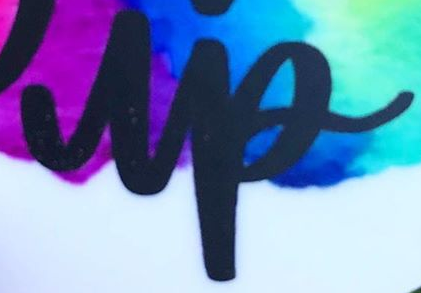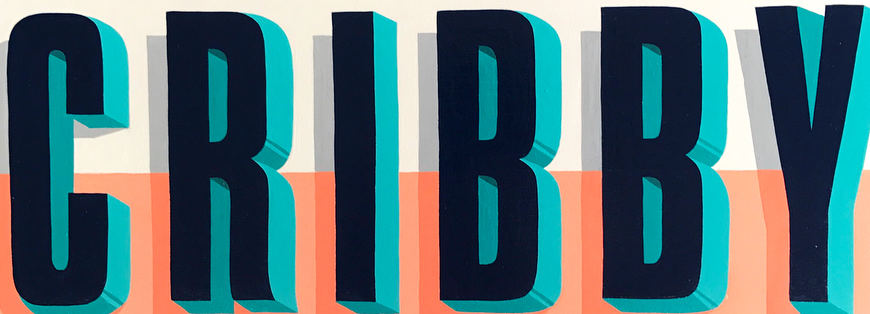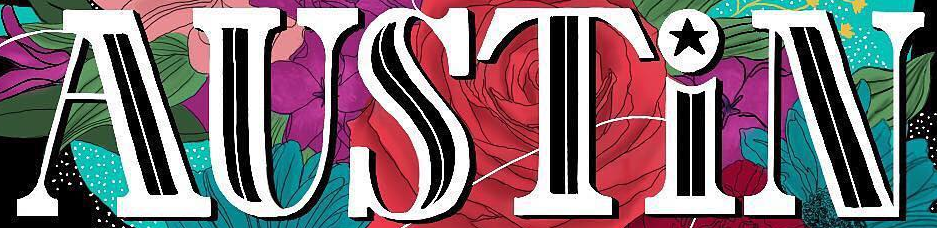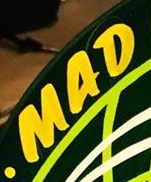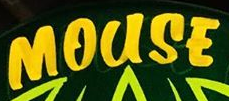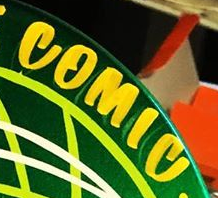Identify the words shown in these images in order, separated by a semicolon. up; CRIBBY; AUSTiN; MAD; MOUSE; COMIC 